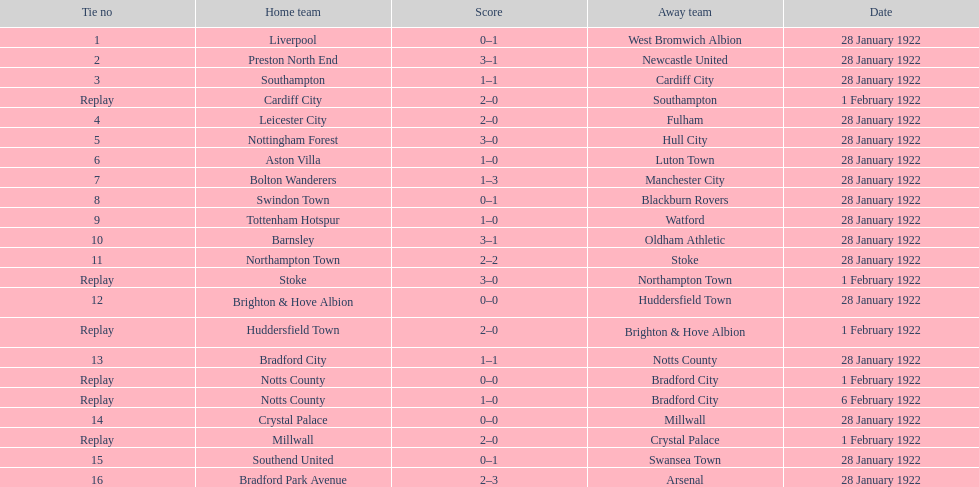How many games had four total points scored or more? 5. 